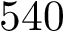Convert formula to latex. <formula><loc_0><loc_0><loc_500><loc_500>5 4 0</formula> 